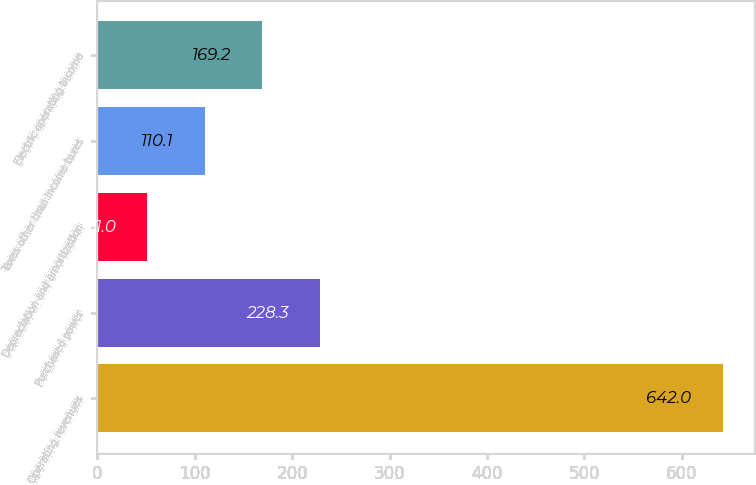<chart> <loc_0><loc_0><loc_500><loc_500><bar_chart><fcel>Operating revenues<fcel>Purchased power<fcel>Depreciation and amortization<fcel>Taxes other than income taxes<fcel>Electric operating income<nl><fcel>642<fcel>228.3<fcel>51<fcel>110.1<fcel>169.2<nl></chart> 